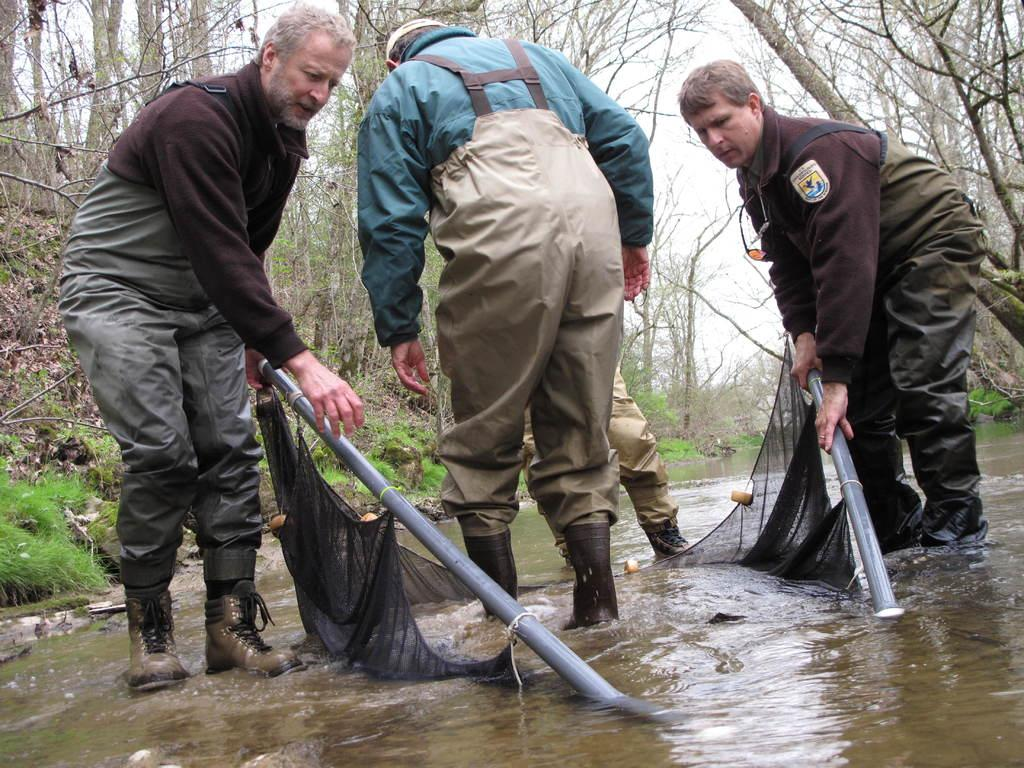How many people are in the image? There are people in the image, but the exact number is not specified. What are the people holding in the image? The people are holding rods in the image. What is attached to the rods? Mesh is tied to the rods. What can be seen in the background of the image? The background includes trees, the sky, and grass. What type of ink can be seen dripping from the feather in the image? There is no feather or ink present in the image. Is there a rabbit visible in the image? No, there is no rabbit visible in the image. 